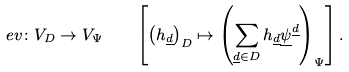<formula> <loc_0><loc_0><loc_500><loc_500>e v \colon V _ { D } \to V _ { \Psi } \quad \left [ \left ( h _ { \underline { d } } \right ) _ { D } \mapsto \left ( \sum _ { \underline { d } \in D } h _ { \underline { d } } \underline { \psi } ^ { \underline { d } } \right ) _ { \Psi } \right ] .</formula> 